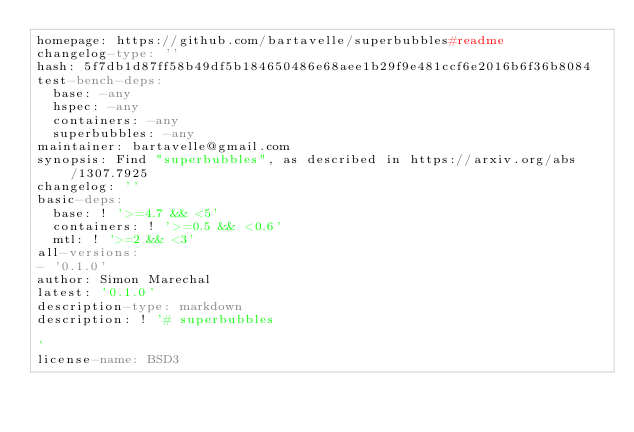Convert code to text. <code><loc_0><loc_0><loc_500><loc_500><_YAML_>homepage: https://github.com/bartavelle/superbubbles#readme
changelog-type: ''
hash: 5f7db1d87ff58b49df5b184650486e68aee1b29f9e481ccf6e2016b6f36b8084
test-bench-deps:
  base: -any
  hspec: -any
  containers: -any
  superbubbles: -any
maintainer: bartavelle@gmail.com
synopsis: Find "superbubbles", as described in https://arxiv.org/abs/1307.7925
changelog: ''
basic-deps:
  base: ! '>=4.7 && <5'
  containers: ! '>=0.5 && <0.6'
  mtl: ! '>=2 && <3'
all-versions:
- '0.1.0'
author: Simon Marechal
latest: '0.1.0'
description-type: markdown
description: ! '# superbubbles

'
license-name: BSD3
</code> 